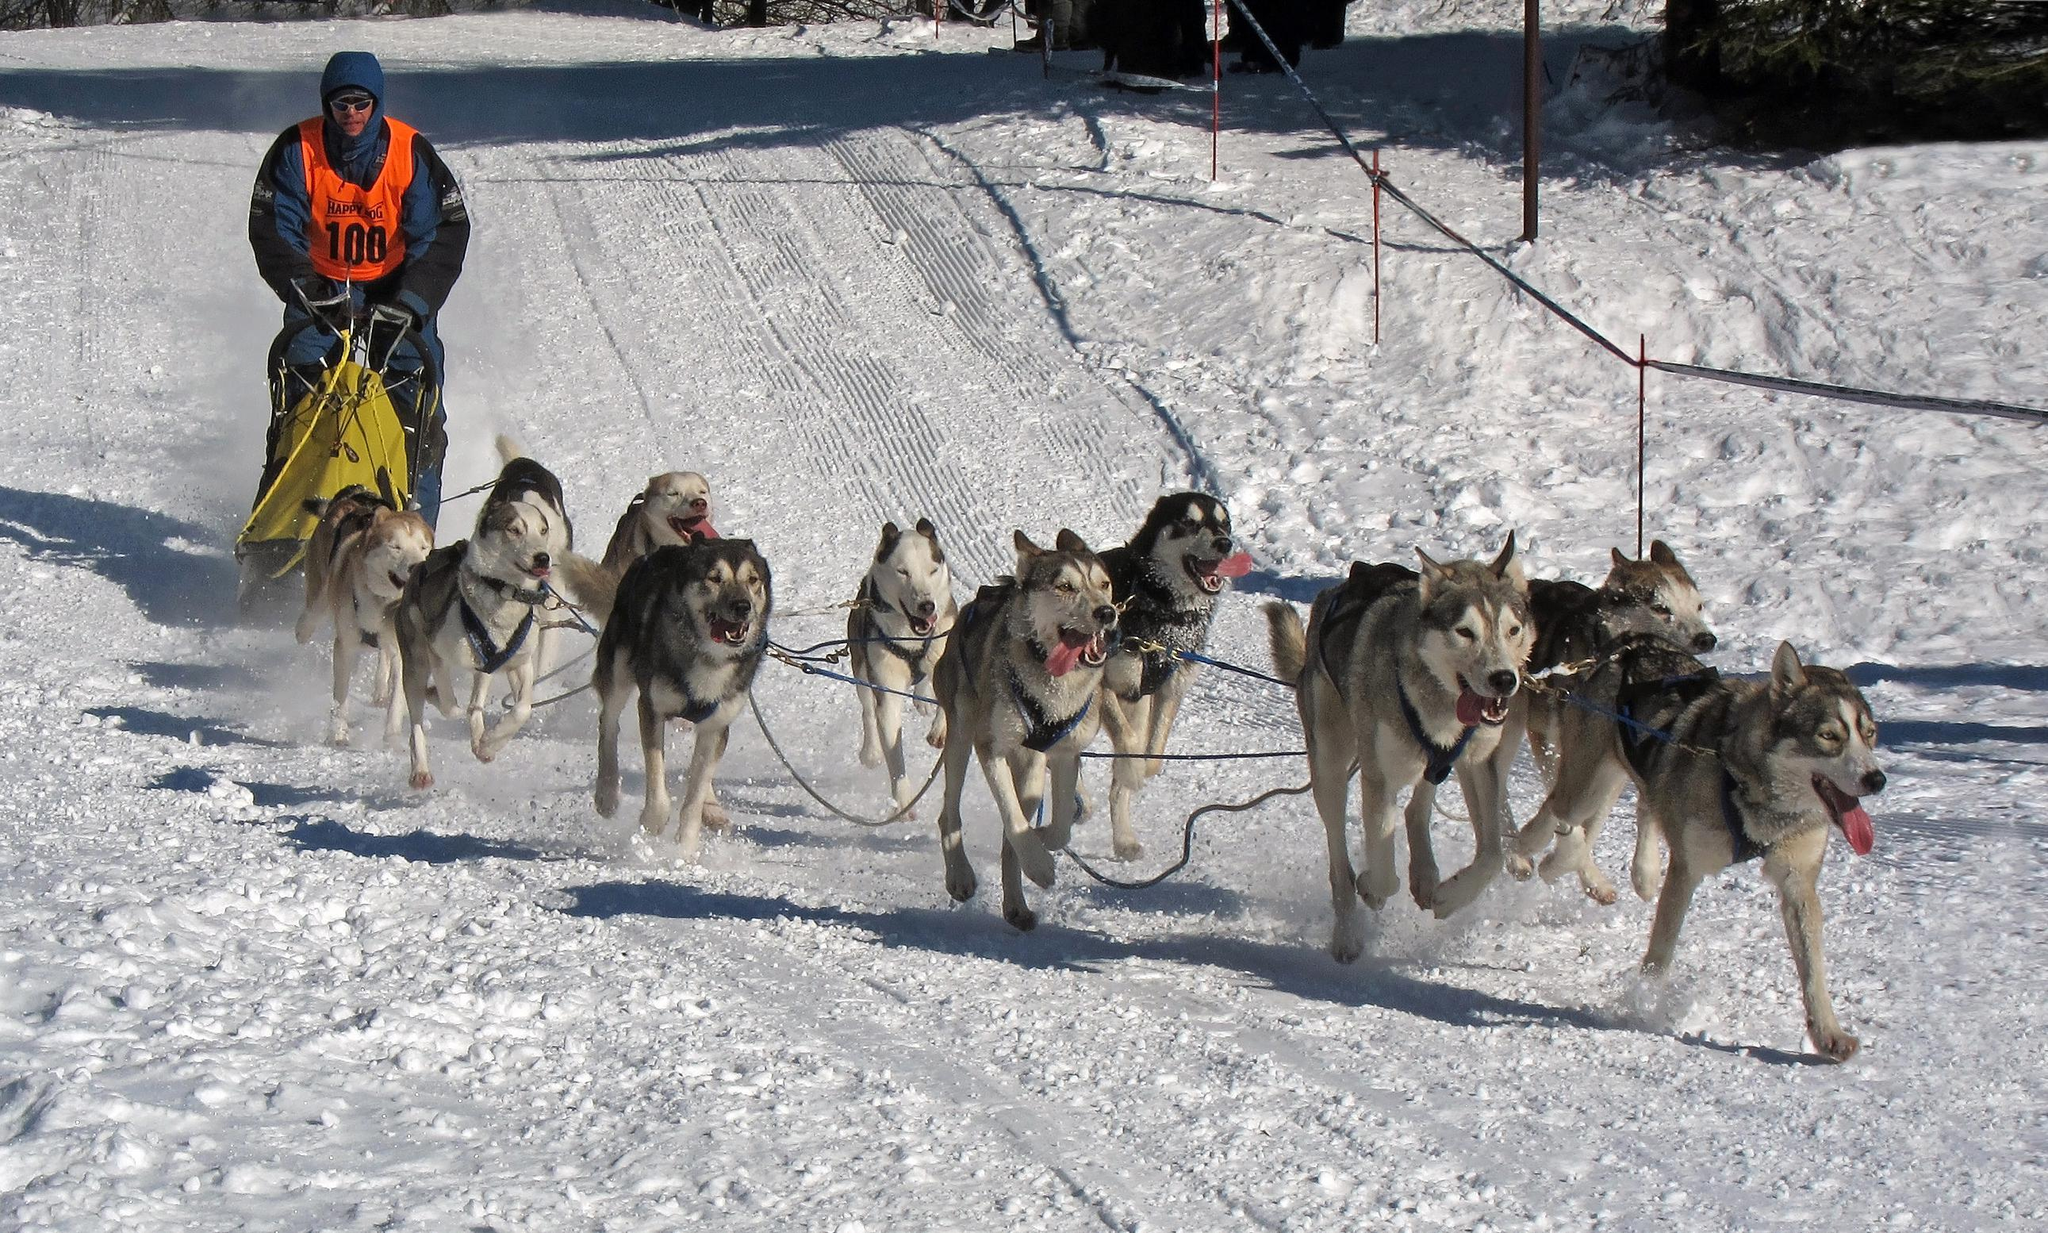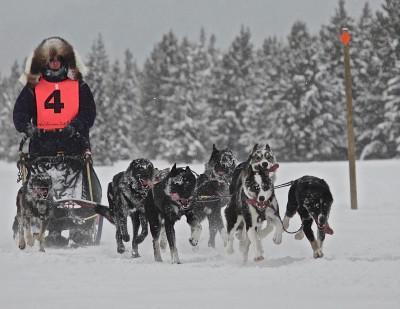The first image is the image on the left, the second image is the image on the right. Considering the images on both sides, is "Three non-canine mammals are visible." valid? Answer yes or no. No. The first image is the image on the left, the second image is the image on the right. For the images shown, is this caption "The dogs are to the right of the sled in both pictures." true? Answer yes or no. Yes. 